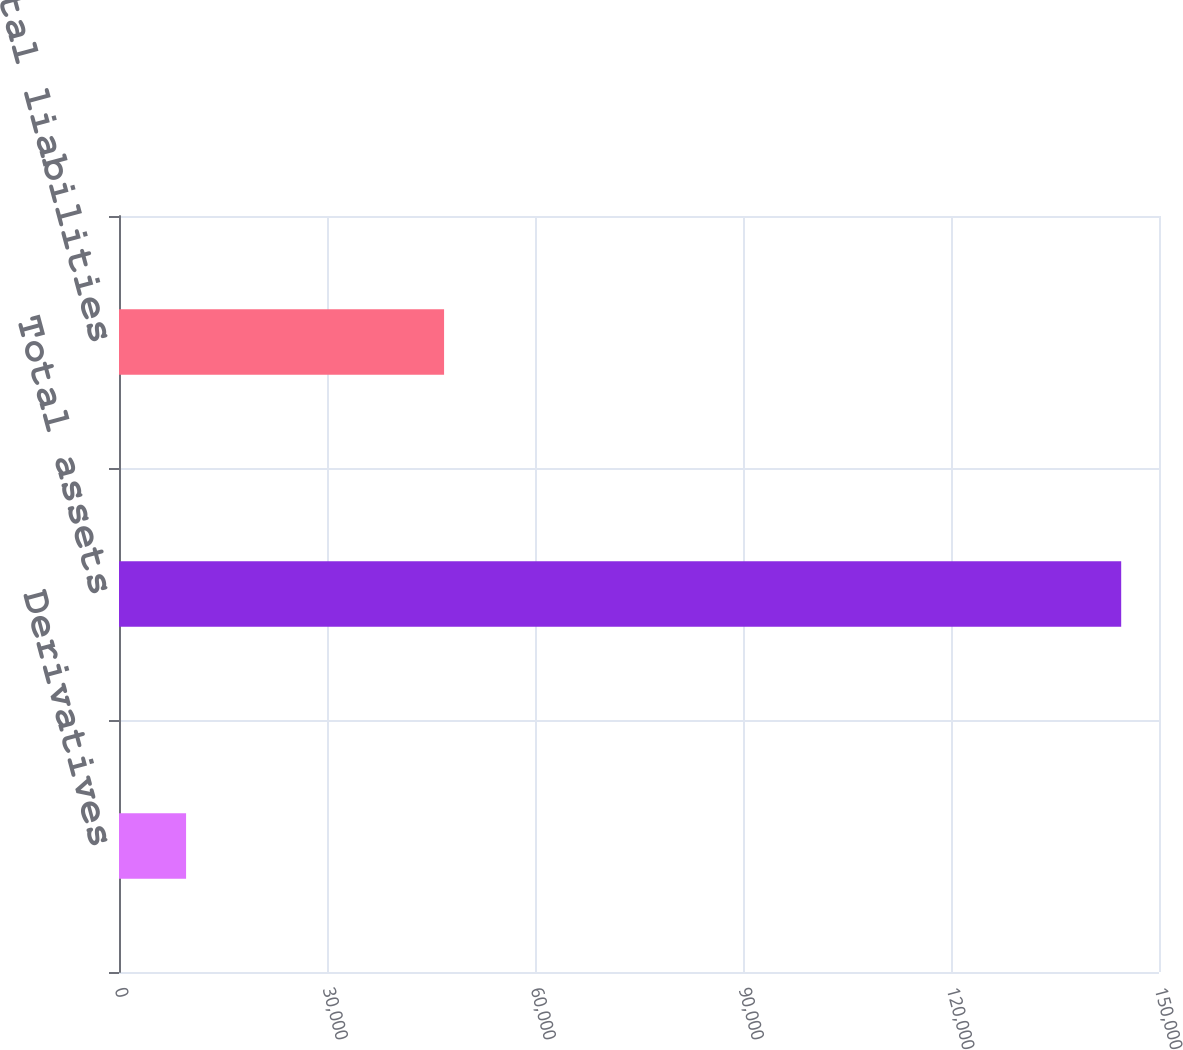Convert chart. <chart><loc_0><loc_0><loc_500><loc_500><bar_chart><fcel>Derivatives<fcel>Total assets<fcel>Total liabilities<nl><fcel>9675<fcel>144547<fcel>46886<nl></chart> 